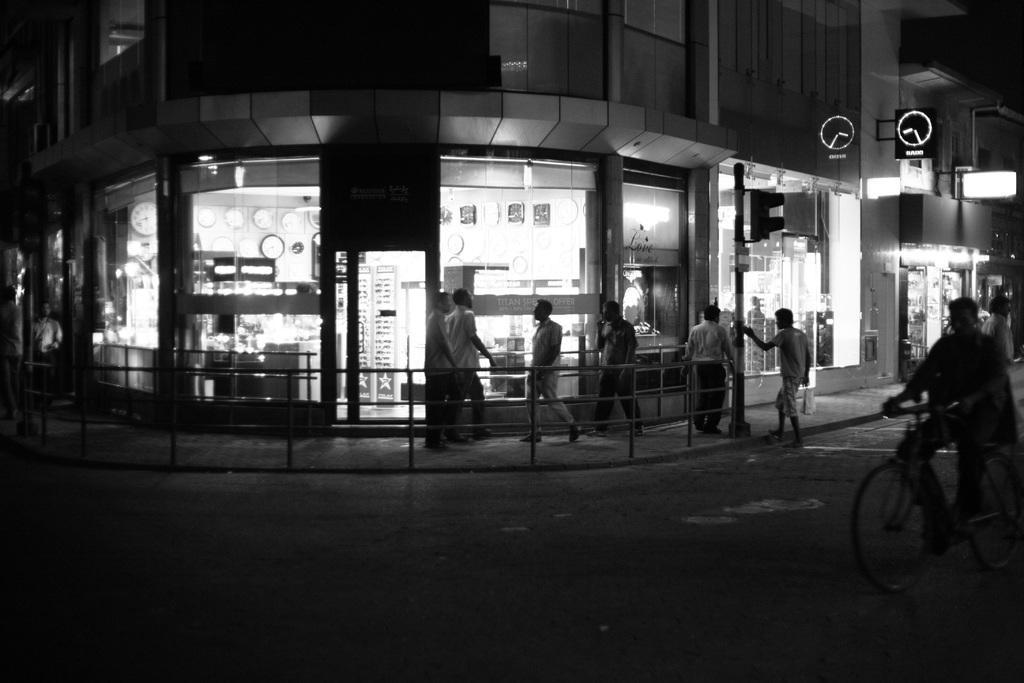In one or two sentences, can you explain what this image depicts? In this image I see few people who are walking on the path and this man is on the cycle. In the background I see building and I see a clock shop over here and I can also see a traffic pole. 